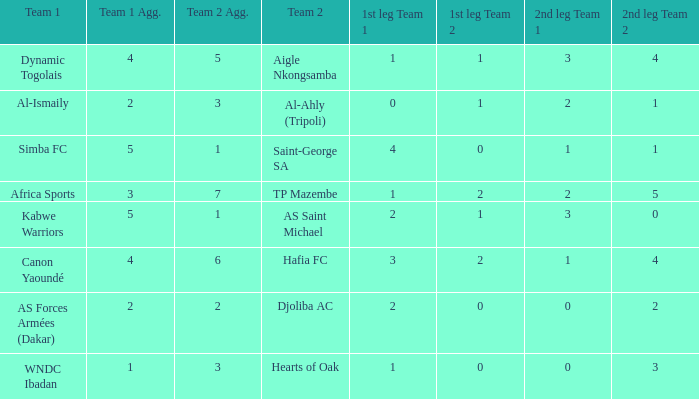What team played against Hafia FC (team 2)? Canon Yaoundé. 